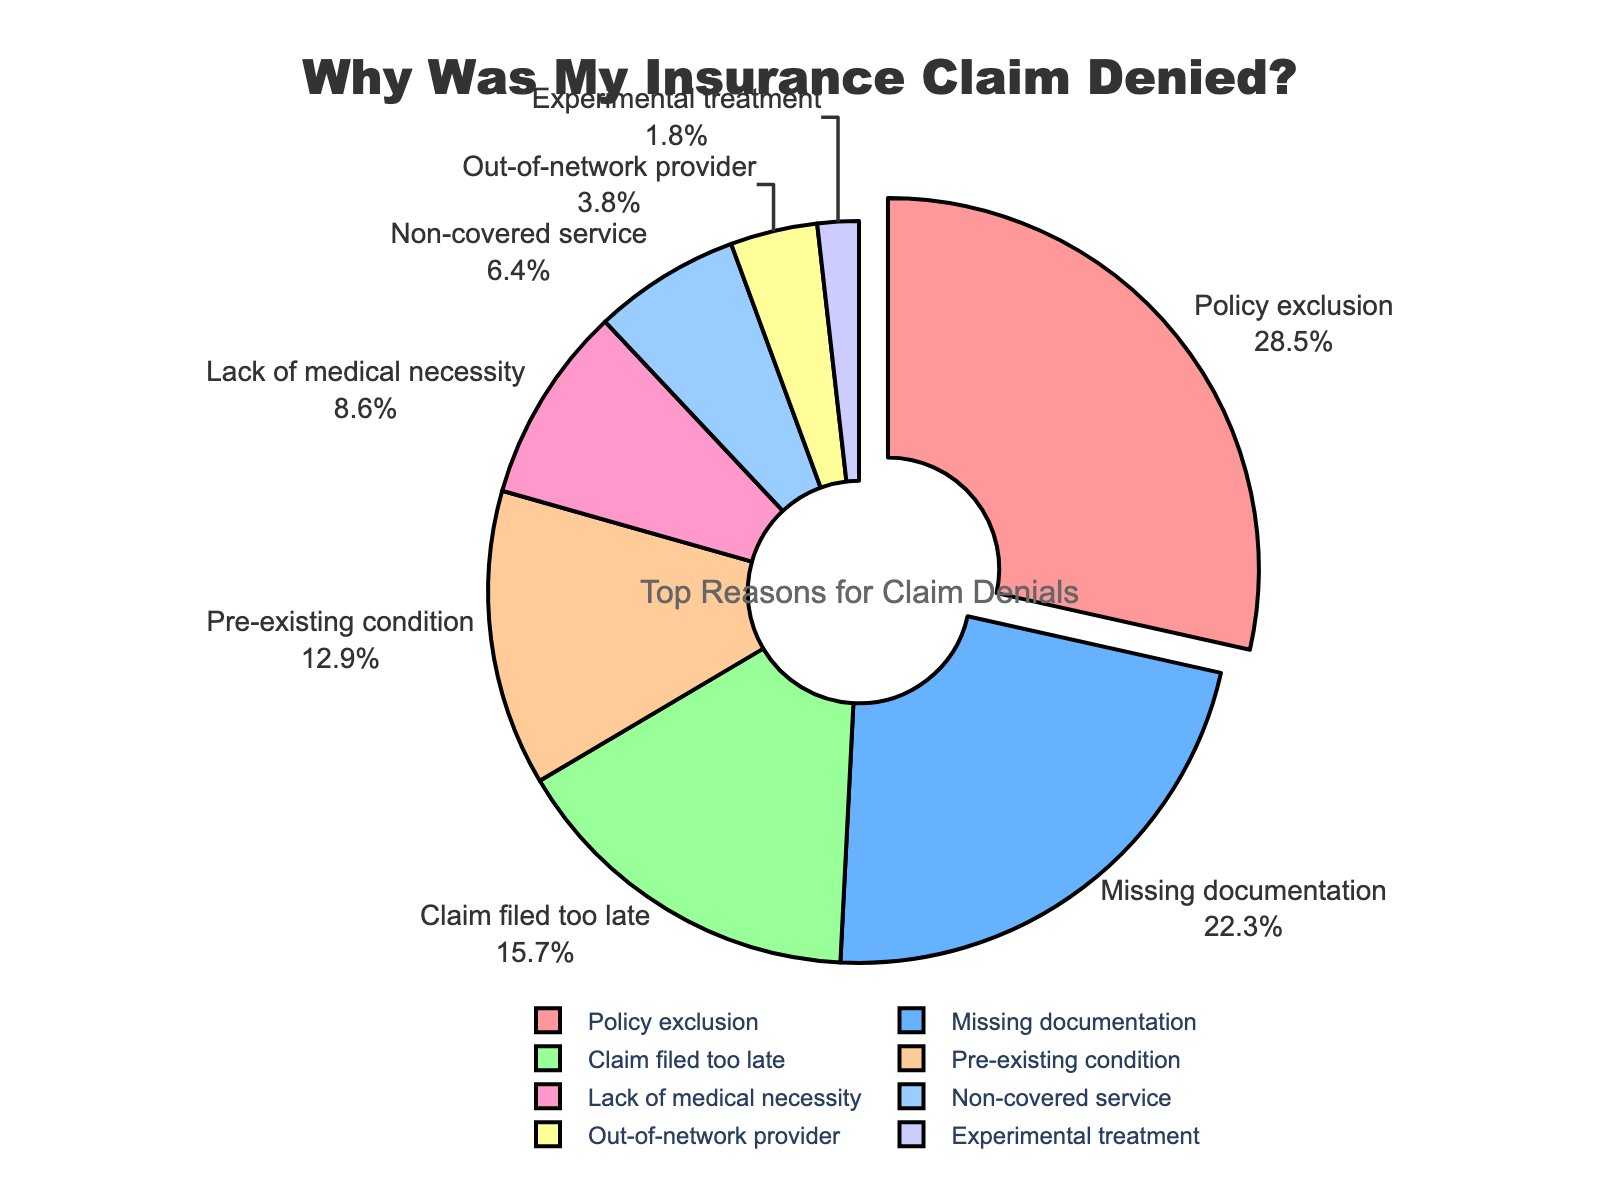What reason accounts for the largest percentage of insurance claim denials? By looking at the pie chart, we can identify that the largest segment corresponds to "Policy exclusion." The percentage listed for this segment is 28.5%.
Answer: Policy exclusion How much larger is the percentage of denials due to "Policy exclusion" compared to "Out-of-network provider"? To find this, we subtract the percentage for "Out-of-network provider" from "Policy exclusion": 28.5% - 3.8% = 24.7%.
Answer: 24.7% Which reasons make up more than 20% of the total denials? By examining the pie chart, we identify two segments with percentages higher than 20%: "Policy exclusion" (28.5%) and "Missing documentation" (22.3%).
Answer: Policy exclusion, Missing documentation Are there more denials due to "Claim filed too late" or "Pre-existing condition"? By comparing the two percentages, we see that "Claim filed too late" is 15.7% and "Pre-existing condition" is 12.9%. 15.7% is greater than 12.9%.
Answer: Claim filed too late What is the combined percentage of denials for "Non-covered service" and "Experimental treatment"? To find the combined percentage, we add the two percentages together: 6.4% + 1.8% = 8.2%.
Answer: 8.2% How many reasons have a percentage lower than 10%? By checking the pie chart, the reasons with percentages lower than 10% are: "Lack of medical necessity" (8.6%), "Non-covered service" (6.4%), "Out-of-network provider" (3.8%), and "Experimental treatment" (1.8%). There are 4 such reasons.
Answer: 4 Rank the reasons from highest to lowest percentage of denials. By observing the pie chart, we can list the reasons in descending order as: "Policy exclusion" (28.5%), "Missing documentation" (22.3%), "Claim filed too late" (15.7%), "Pre-existing condition" (12.9%), "Lack of medical necessity" (8.6%), "Non-covered service" (6.4%), "Out-of-network provider" (3.8%), and "Experimental treatment" (1.8%).
Answer: Policy exclusion, Missing documentation, Claim filed too late, Pre-existing condition, Lack of medical necessity, Non-covered service, Out-of-network provider, Experimental treatment What percentage of the total denials is made up by "Pre-existing condition" and "Missing documentation" combined? Adding the percentages for "Pre-existing condition" (12.9%) and "Missing documentation" (22.3%), we get 12.9% + 22.3% = 35.2%.
Answer: 35.2% Which reason represents the smallest percentage of denials? Reviewing the pie chart, the smallest segment corresponds to "Experimental treatment" with a percentage of 1.8%.
Answer: Experimental treatment 